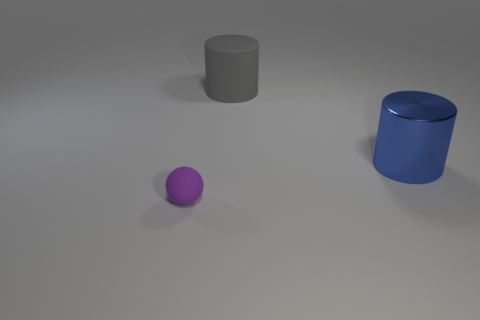Add 3 big red metallic spheres. How many objects exist? 6 Subtract all balls. How many objects are left? 2 Subtract all tiny cyan shiny balls. Subtract all big gray rubber things. How many objects are left? 2 Add 1 tiny balls. How many tiny balls are left? 2 Add 1 big blue cylinders. How many big blue cylinders exist? 2 Subtract 0 cyan blocks. How many objects are left? 3 